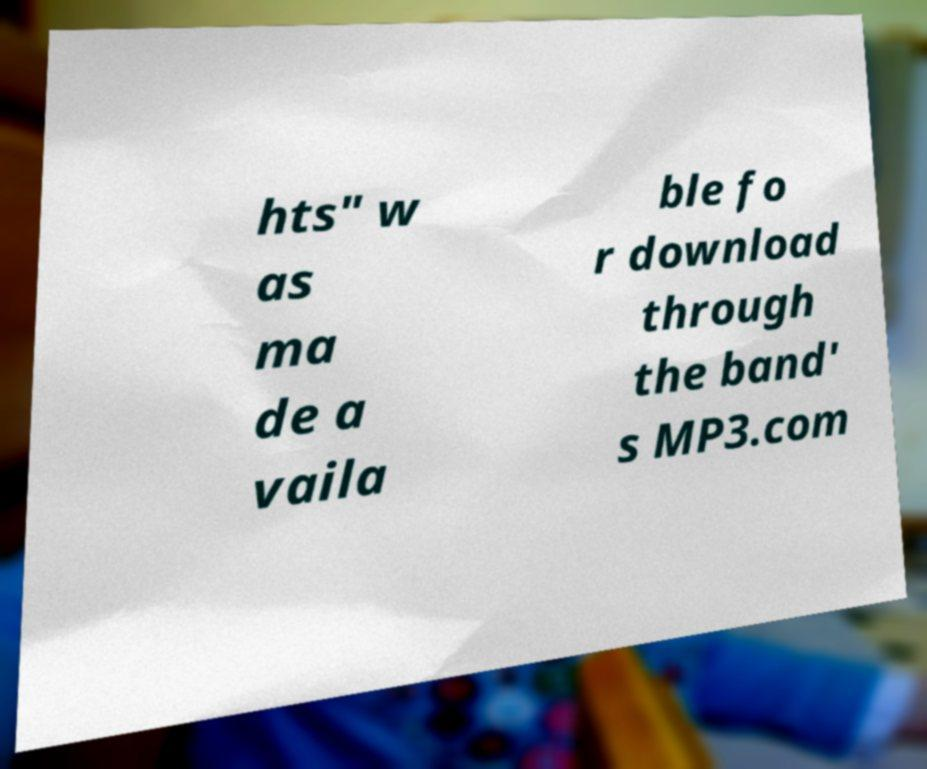For documentation purposes, I need the text within this image transcribed. Could you provide that? hts" w as ma de a vaila ble fo r download through the band' s MP3.com 